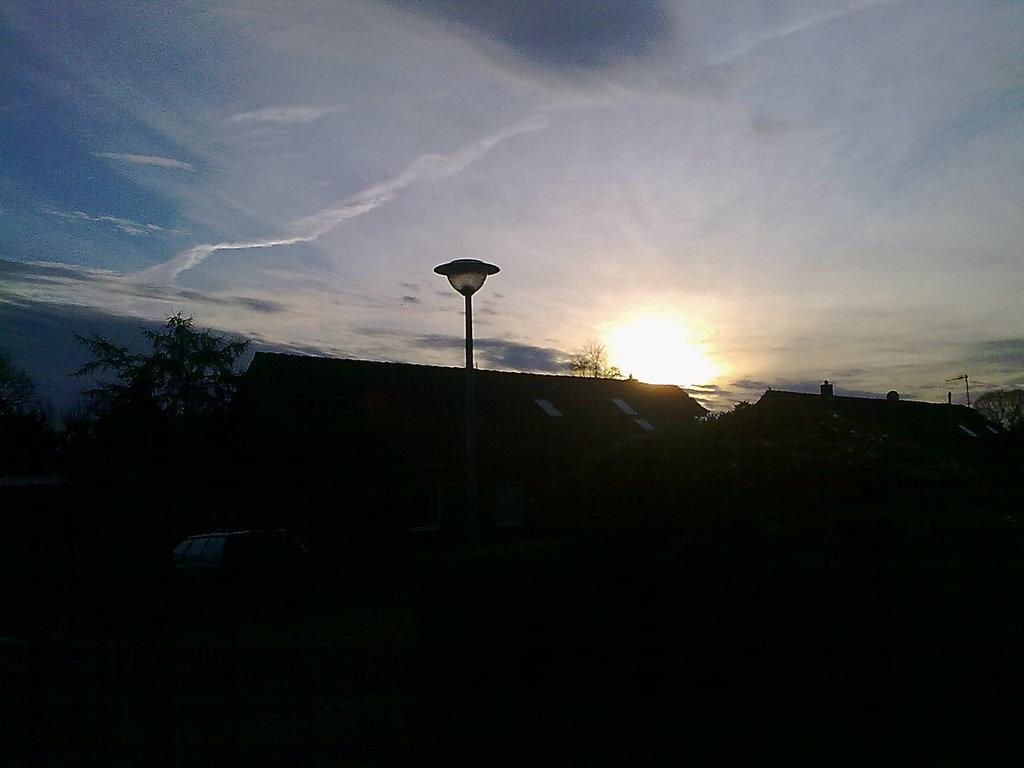What type of structures can be seen in the image? There are houses in the image. What is happening on the road in the image? There is a vehicle moving on the road in the image. What type of vegetation is present in the image? There are trees in the image. What can be seen in the background of the image? The sky is visible in the background of the image, and the sun is observable in the sky. Where is the spade located in the image? There is no spade present in the image. What type of medical facility can be seen in the image? There is no hospital present in the image. 